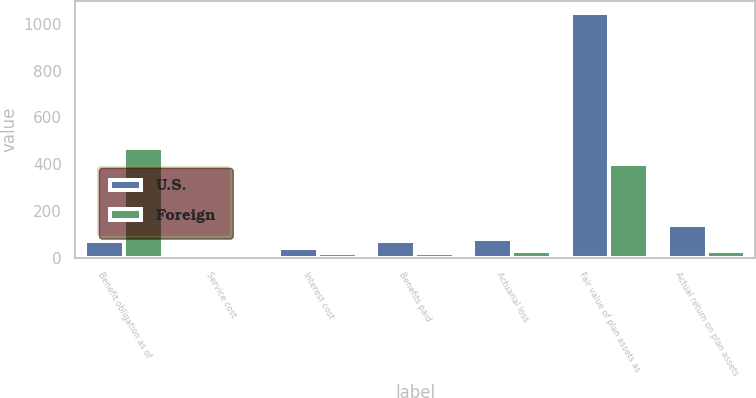Convert chart. <chart><loc_0><loc_0><loc_500><loc_500><stacked_bar_chart><ecel><fcel>Benefit obligation as of<fcel>Service cost<fcel>Interest cost<fcel>Benefits paid<fcel>Actuarial loss<fcel>Fair value of plan assets as<fcel>Actual return on plan assets<nl><fcel>U.S.<fcel>71<fcel>13<fcel>41<fcel>71<fcel>82<fcel>1044<fcel>141<nl><fcel>Foreign<fcel>470<fcel>10<fcel>22<fcel>22<fcel>29<fcel>402<fcel>31<nl></chart> 